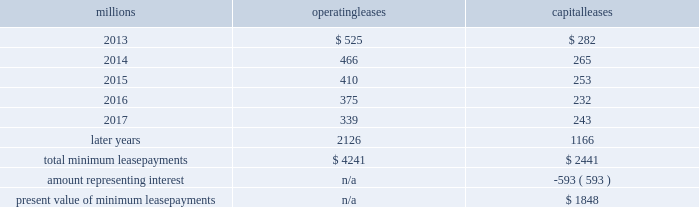Fixed-price purchase options available in the leases could potentially provide benefits to us ; however , these benefits are not expected to be significant .
We maintain and operate the assets based on contractual obligations within the lease arrangements , which set specific guidelines consistent within the railroad industry .
As such , we have no control over activities that could materially impact the fair value of the leased assets .
We do not hold the power to direct the activities of the vies and , therefore , do not control the ongoing activities that have a significant impact on the economic performance of the vies .
Additionally , we do not have the obligation to absorb losses of the vies or the right to receive benefits of the vies that could potentially be significant to the we are not considered to be the primary beneficiary and do not consolidate these vies because our actions and decisions do not have the most significant effect on the vie 2019s performance and our fixed-price purchase price options are not considered to be potentially significant to the vie 2019s .
The future minimum lease payments associated with the vie leases totaled $ 3.6 billion as of december 31 , 2012 .
16 .
Leases we lease certain locomotives , freight cars , and other property .
The consolidated statements of financial position as of december 31 , 2012 and 2011 included $ 2467 million , net of $ 966 million of accumulated depreciation , and $ 2458 million , net of $ 915 million of accumulated depreciation , respectively , for properties held under capital leases .
A charge to income resulting from the depreciation for assets held under capital leases is included within depreciation expense in our consolidated statements of income .
Future minimum lease payments for operating and capital leases with initial or remaining non-cancelable lease terms in excess of one year as of december 31 , 2012 , were as follows : millions operating leases capital leases .
Approximately 94% ( 94 % ) of capital lease payments relate to locomotives .
Rent expense for operating leases with terms exceeding one month was $ 631 million in 2012 , $ 637 million in 2011 , and $ 624 million in 2010 .
When cash rental payments are not made on a straight-line basis , we recognize variable rental expense on a straight-line basis over the lease term .
Contingent rentals and sub-rentals are not significant .
17 .
Commitments and contingencies asserted and unasserted claims 2013 various claims and lawsuits are pending against us and certain of our subsidiaries .
We cannot fully determine the effect of all asserted and unasserted claims on our consolidated results of operations , financial condition , or liquidity ; however , to the extent possible , where asserted and unasserted claims are considered probable and where such claims can be reasonably estimated , we have recorded a liability .
We do not expect that any known lawsuits , claims , environmental costs , commitments , contingent liabilities , or guarantees will have a material adverse effect on our consolidated results of operations , financial condition , or liquidity after taking into account liabilities and insurance recoveries previously recorded for these matters .
Personal injury 2013 the cost of personal injuries to employees and others related to our activities is charged to expense based on estimates of the ultimate cost and number of incidents each year .
We use an actuarial analysis to measure the expense and liability , including unasserted claims .
The federal employers 2019 liability act ( fela ) governs compensation for work-related accidents .
Under fela , damages .
What is the total capital lease payments due for locomotives , in millions? 
Computations: (2441 * 94%)
Answer: 2294.54. 